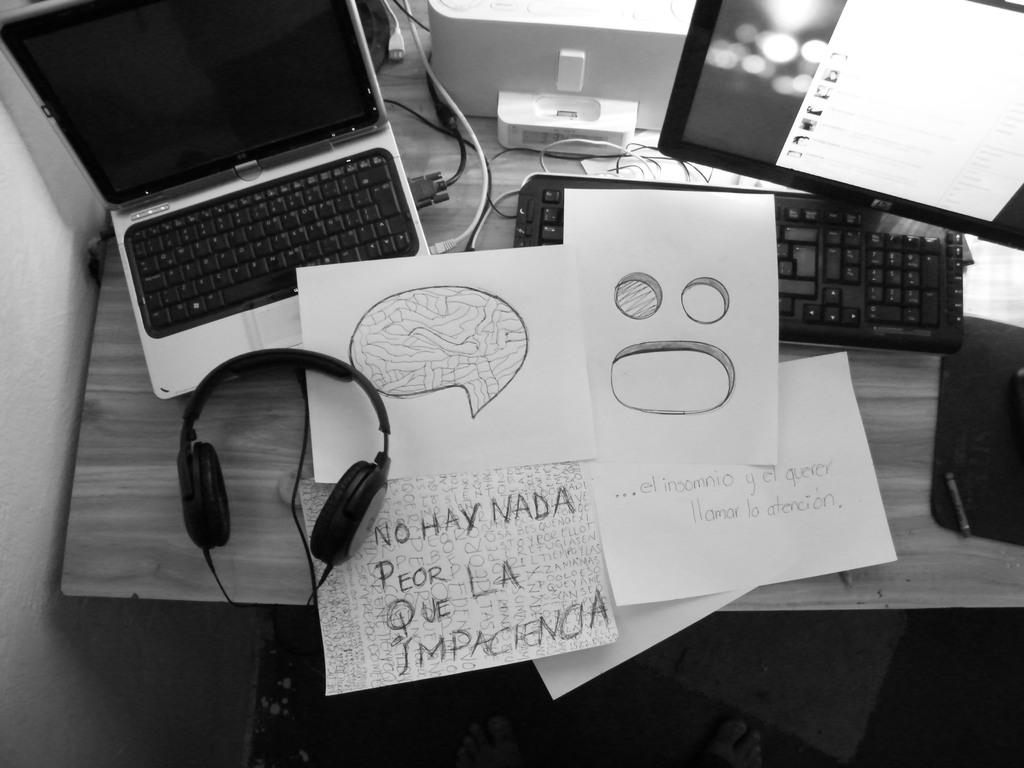What electronic device is visible in the image? There is a laptop in the image. What other computer-related items can be seen in the image? There is a keyboard and a monitor in the image. What type of document or material is present in the image? There are papers in the image. What accessory is visible in the image that might be used for listening to audio? There is a headphone in the image. Where are all these items located in the image? All these items are on a table. What type of cough can be heard coming from the laptop in the image? There is no sound or cough coming from the laptop in the image; it is an electronic device. 